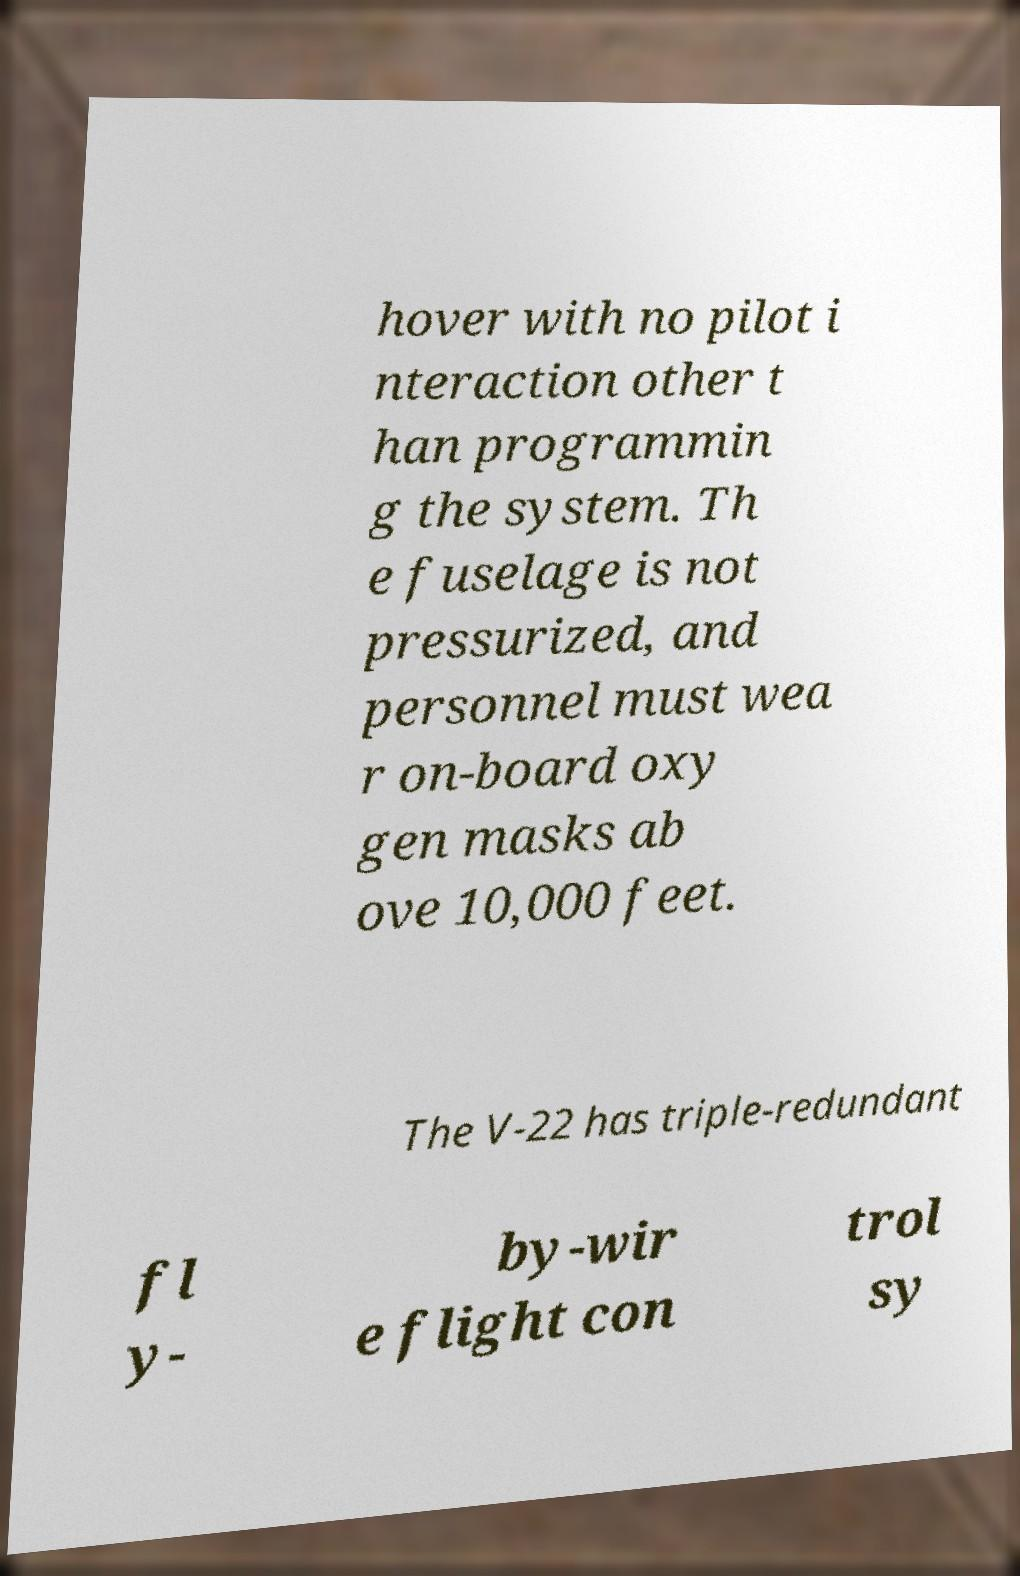What messages or text are displayed in this image? I need them in a readable, typed format. hover with no pilot i nteraction other t han programmin g the system. Th e fuselage is not pressurized, and personnel must wea r on-board oxy gen masks ab ove 10,000 feet. The V-22 has triple-redundant fl y- by-wir e flight con trol sy 